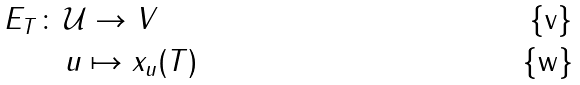<formula> <loc_0><loc_0><loc_500><loc_500>E _ { T } \colon \, & \mathcal { U } \to V \\ & u \mapsto x _ { u } ( T )</formula> 